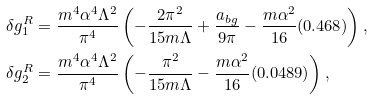<formula> <loc_0><loc_0><loc_500><loc_500>\delta g ^ { R } _ { 1 } & = \frac { m ^ { 4 } \alpha ^ { 4 } \Lambda ^ { 2 } } { \pi ^ { 4 } } \left ( - \frac { 2 \pi ^ { 2 } } { 1 5 m \Lambda } + \frac { a _ { b g } } { 9 \pi } - \frac { m \alpha ^ { 2 } } { 1 6 } ( 0 . 4 6 8 ) \right ) , \\ \delta g ^ { R } _ { 2 } & = \frac { m ^ { 4 } \alpha ^ { 4 } \Lambda ^ { 2 } } { \pi ^ { 4 } } \left ( - \frac { \pi ^ { 2 } } { 1 5 m \Lambda } - \frac { m \alpha ^ { 2 } } { 1 6 } ( 0 . 0 4 8 9 ) \right ) ,</formula> 